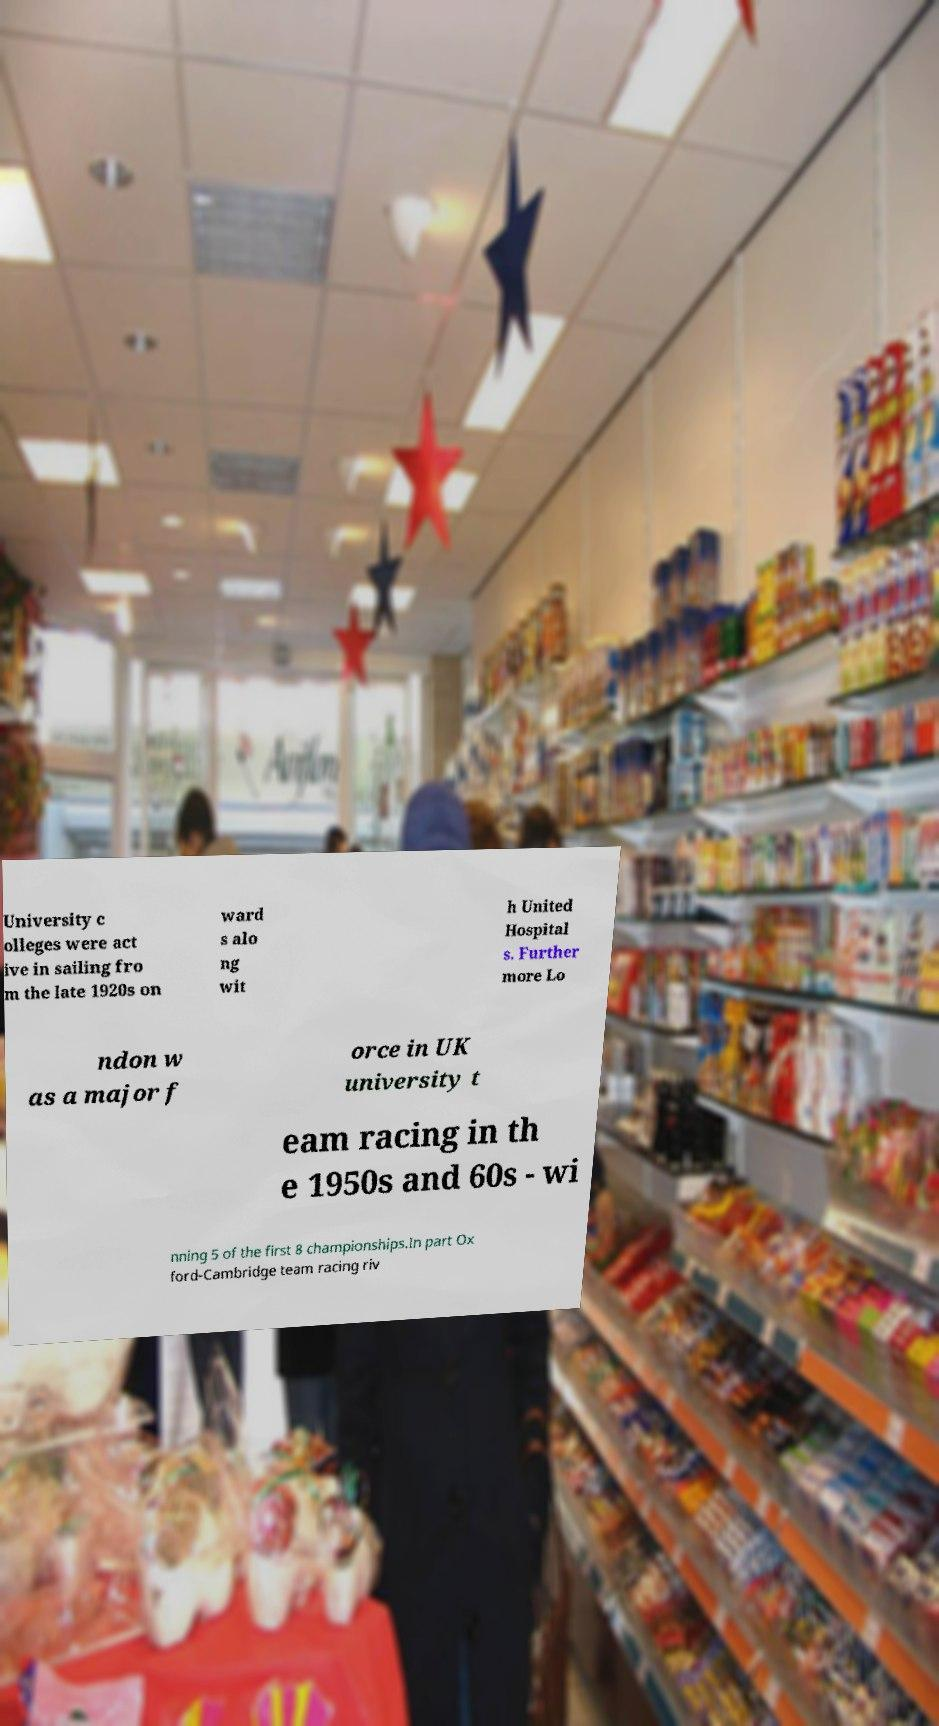There's text embedded in this image that I need extracted. Can you transcribe it verbatim? University c olleges were act ive in sailing fro m the late 1920s on ward s alo ng wit h United Hospital s. Further more Lo ndon w as a major f orce in UK university t eam racing in th e 1950s and 60s - wi nning 5 of the first 8 championships.In part Ox ford-Cambridge team racing riv 